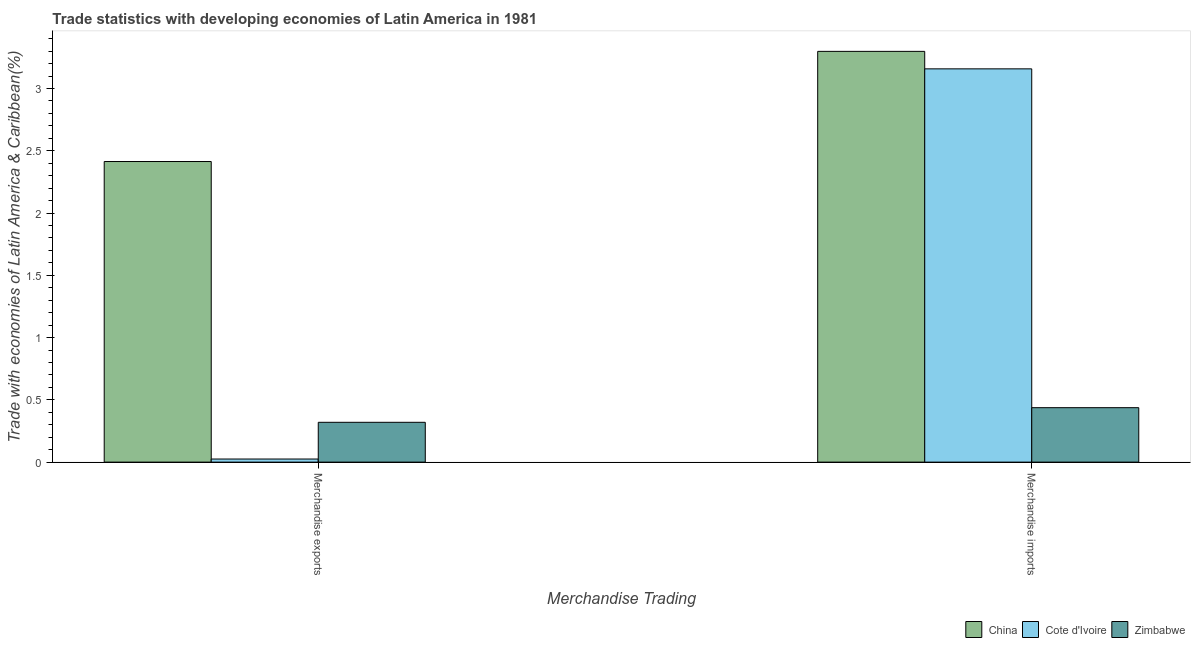How many different coloured bars are there?
Provide a succinct answer. 3. How many groups of bars are there?
Make the answer very short. 2. Are the number of bars on each tick of the X-axis equal?
Your response must be concise. Yes. How many bars are there on the 2nd tick from the right?
Your answer should be compact. 3. What is the label of the 1st group of bars from the left?
Your answer should be very brief. Merchandise exports. What is the merchandise exports in Cote d'Ivoire?
Offer a very short reply. 0.02. Across all countries, what is the maximum merchandise exports?
Offer a very short reply. 2.41. Across all countries, what is the minimum merchandise imports?
Provide a succinct answer. 0.44. In which country was the merchandise imports maximum?
Keep it short and to the point. China. In which country was the merchandise imports minimum?
Keep it short and to the point. Zimbabwe. What is the total merchandise exports in the graph?
Ensure brevity in your answer.  2.76. What is the difference between the merchandise exports in Zimbabwe and that in China?
Give a very brief answer. -2.09. What is the difference between the merchandise exports in Cote d'Ivoire and the merchandise imports in Zimbabwe?
Offer a very short reply. -0.41. What is the average merchandise exports per country?
Give a very brief answer. 0.92. What is the difference between the merchandise exports and merchandise imports in Cote d'Ivoire?
Give a very brief answer. -3.13. In how many countries, is the merchandise exports greater than 2.5 %?
Ensure brevity in your answer.  0. What is the ratio of the merchandise exports in Zimbabwe to that in China?
Give a very brief answer. 0.13. Is the merchandise exports in Cote d'Ivoire less than that in Zimbabwe?
Make the answer very short. Yes. In how many countries, is the merchandise exports greater than the average merchandise exports taken over all countries?
Your response must be concise. 1. What does the 2nd bar from the left in Merchandise imports represents?
Keep it short and to the point. Cote d'Ivoire. What does the 3rd bar from the right in Merchandise exports represents?
Give a very brief answer. China. How many bars are there?
Your answer should be very brief. 6. Are all the bars in the graph horizontal?
Keep it short and to the point. No. What is the difference between two consecutive major ticks on the Y-axis?
Give a very brief answer. 0.5. Are the values on the major ticks of Y-axis written in scientific E-notation?
Provide a succinct answer. No. Does the graph contain any zero values?
Offer a very short reply. No. Where does the legend appear in the graph?
Your response must be concise. Bottom right. How are the legend labels stacked?
Your response must be concise. Horizontal. What is the title of the graph?
Provide a succinct answer. Trade statistics with developing economies of Latin America in 1981. What is the label or title of the X-axis?
Your response must be concise. Merchandise Trading. What is the label or title of the Y-axis?
Offer a very short reply. Trade with economies of Latin America & Caribbean(%). What is the Trade with economies of Latin America & Caribbean(%) of China in Merchandise exports?
Make the answer very short. 2.41. What is the Trade with economies of Latin America & Caribbean(%) in Cote d'Ivoire in Merchandise exports?
Make the answer very short. 0.02. What is the Trade with economies of Latin America & Caribbean(%) of Zimbabwe in Merchandise exports?
Ensure brevity in your answer.  0.32. What is the Trade with economies of Latin America & Caribbean(%) of China in Merchandise imports?
Give a very brief answer. 3.3. What is the Trade with economies of Latin America & Caribbean(%) of Cote d'Ivoire in Merchandise imports?
Provide a short and direct response. 3.16. What is the Trade with economies of Latin America & Caribbean(%) of Zimbabwe in Merchandise imports?
Your answer should be compact. 0.44. Across all Merchandise Trading, what is the maximum Trade with economies of Latin America & Caribbean(%) of China?
Provide a short and direct response. 3.3. Across all Merchandise Trading, what is the maximum Trade with economies of Latin America & Caribbean(%) of Cote d'Ivoire?
Ensure brevity in your answer.  3.16. Across all Merchandise Trading, what is the maximum Trade with economies of Latin America & Caribbean(%) of Zimbabwe?
Ensure brevity in your answer.  0.44. Across all Merchandise Trading, what is the minimum Trade with economies of Latin America & Caribbean(%) in China?
Ensure brevity in your answer.  2.41. Across all Merchandise Trading, what is the minimum Trade with economies of Latin America & Caribbean(%) in Cote d'Ivoire?
Ensure brevity in your answer.  0.02. Across all Merchandise Trading, what is the minimum Trade with economies of Latin America & Caribbean(%) in Zimbabwe?
Your answer should be very brief. 0.32. What is the total Trade with economies of Latin America & Caribbean(%) in China in the graph?
Your answer should be compact. 5.71. What is the total Trade with economies of Latin America & Caribbean(%) in Cote d'Ivoire in the graph?
Your answer should be compact. 3.18. What is the total Trade with economies of Latin America & Caribbean(%) of Zimbabwe in the graph?
Offer a terse response. 0.76. What is the difference between the Trade with economies of Latin America & Caribbean(%) of China in Merchandise exports and that in Merchandise imports?
Offer a terse response. -0.88. What is the difference between the Trade with economies of Latin America & Caribbean(%) in Cote d'Ivoire in Merchandise exports and that in Merchandise imports?
Your answer should be compact. -3.13. What is the difference between the Trade with economies of Latin America & Caribbean(%) in Zimbabwe in Merchandise exports and that in Merchandise imports?
Give a very brief answer. -0.12. What is the difference between the Trade with economies of Latin America & Caribbean(%) of China in Merchandise exports and the Trade with economies of Latin America & Caribbean(%) of Cote d'Ivoire in Merchandise imports?
Your answer should be very brief. -0.74. What is the difference between the Trade with economies of Latin America & Caribbean(%) in China in Merchandise exports and the Trade with economies of Latin America & Caribbean(%) in Zimbabwe in Merchandise imports?
Offer a terse response. 1.98. What is the difference between the Trade with economies of Latin America & Caribbean(%) of Cote d'Ivoire in Merchandise exports and the Trade with economies of Latin America & Caribbean(%) of Zimbabwe in Merchandise imports?
Provide a short and direct response. -0.41. What is the average Trade with economies of Latin America & Caribbean(%) of China per Merchandise Trading?
Provide a succinct answer. 2.86. What is the average Trade with economies of Latin America & Caribbean(%) of Cote d'Ivoire per Merchandise Trading?
Offer a very short reply. 1.59. What is the average Trade with economies of Latin America & Caribbean(%) in Zimbabwe per Merchandise Trading?
Keep it short and to the point. 0.38. What is the difference between the Trade with economies of Latin America & Caribbean(%) of China and Trade with economies of Latin America & Caribbean(%) of Cote d'Ivoire in Merchandise exports?
Keep it short and to the point. 2.39. What is the difference between the Trade with economies of Latin America & Caribbean(%) of China and Trade with economies of Latin America & Caribbean(%) of Zimbabwe in Merchandise exports?
Provide a short and direct response. 2.09. What is the difference between the Trade with economies of Latin America & Caribbean(%) in Cote d'Ivoire and Trade with economies of Latin America & Caribbean(%) in Zimbabwe in Merchandise exports?
Give a very brief answer. -0.29. What is the difference between the Trade with economies of Latin America & Caribbean(%) of China and Trade with economies of Latin America & Caribbean(%) of Cote d'Ivoire in Merchandise imports?
Your answer should be very brief. 0.14. What is the difference between the Trade with economies of Latin America & Caribbean(%) in China and Trade with economies of Latin America & Caribbean(%) in Zimbabwe in Merchandise imports?
Offer a terse response. 2.86. What is the difference between the Trade with economies of Latin America & Caribbean(%) in Cote d'Ivoire and Trade with economies of Latin America & Caribbean(%) in Zimbabwe in Merchandise imports?
Provide a succinct answer. 2.72. What is the ratio of the Trade with economies of Latin America & Caribbean(%) in China in Merchandise exports to that in Merchandise imports?
Offer a terse response. 0.73. What is the ratio of the Trade with economies of Latin America & Caribbean(%) of Cote d'Ivoire in Merchandise exports to that in Merchandise imports?
Keep it short and to the point. 0.01. What is the ratio of the Trade with economies of Latin America & Caribbean(%) of Zimbabwe in Merchandise exports to that in Merchandise imports?
Keep it short and to the point. 0.73. What is the difference between the highest and the second highest Trade with economies of Latin America & Caribbean(%) of China?
Ensure brevity in your answer.  0.88. What is the difference between the highest and the second highest Trade with economies of Latin America & Caribbean(%) of Cote d'Ivoire?
Your answer should be very brief. 3.13. What is the difference between the highest and the second highest Trade with economies of Latin America & Caribbean(%) of Zimbabwe?
Provide a short and direct response. 0.12. What is the difference between the highest and the lowest Trade with economies of Latin America & Caribbean(%) in China?
Provide a succinct answer. 0.88. What is the difference between the highest and the lowest Trade with economies of Latin America & Caribbean(%) in Cote d'Ivoire?
Your answer should be very brief. 3.13. What is the difference between the highest and the lowest Trade with economies of Latin America & Caribbean(%) of Zimbabwe?
Make the answer very short. 0.12. 